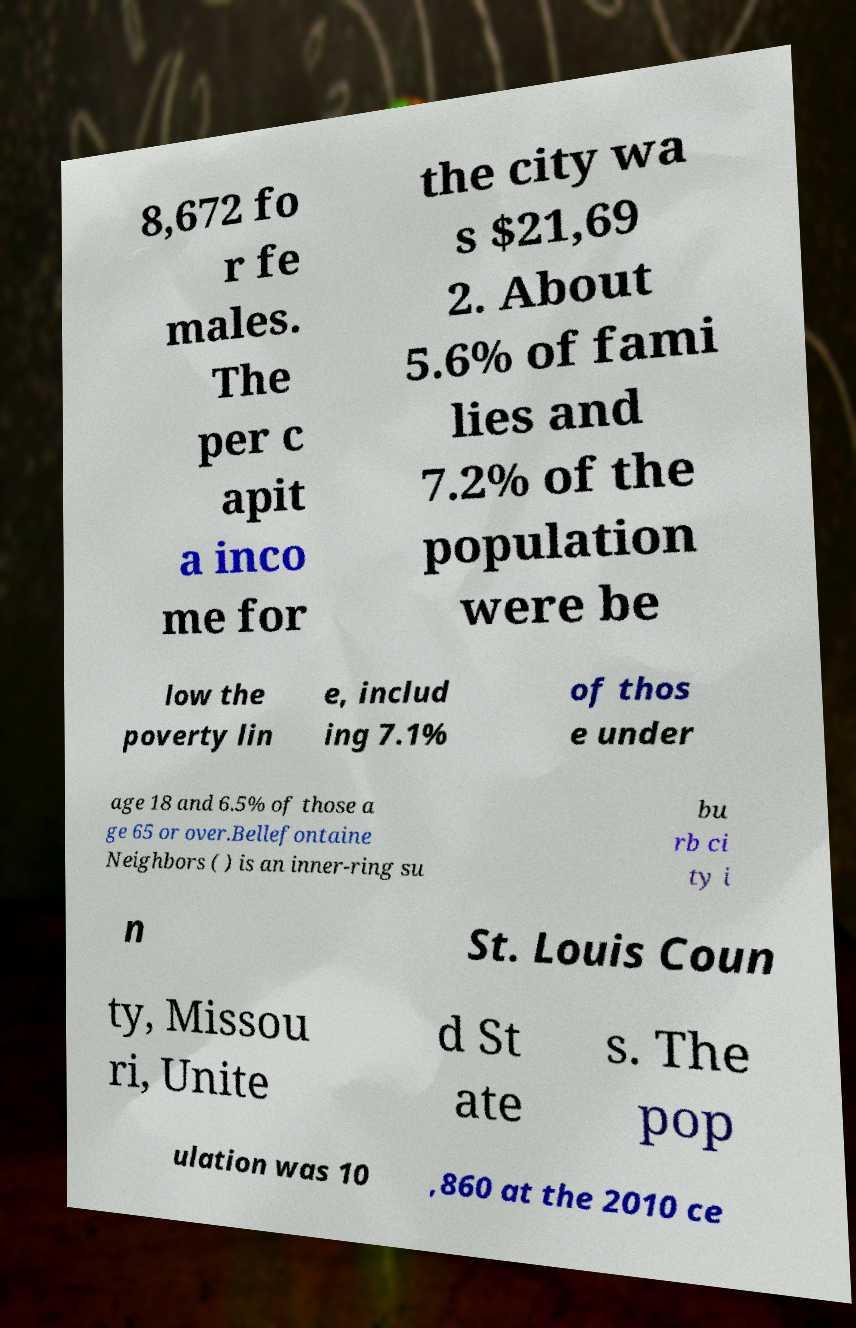Please read and relay the text visible in this image. What does it say? 8,672 fo r fe males. The per c apit a inco me for the city wa s $21,69 2. About 5.6% of fami lies and 7.2% of the population were be low the poverty lin e, includ ing 7.1% of thos e under age 18 and 6.5% of those a ge 65 or over.Bellefontaine Neighbors ( ) is an inner-ring su bu rb ci ty i n St. Louis Coun ty, Missou ri, Unite d St ate s. The pop ulation was 10 ,860 at the 2010 ce 